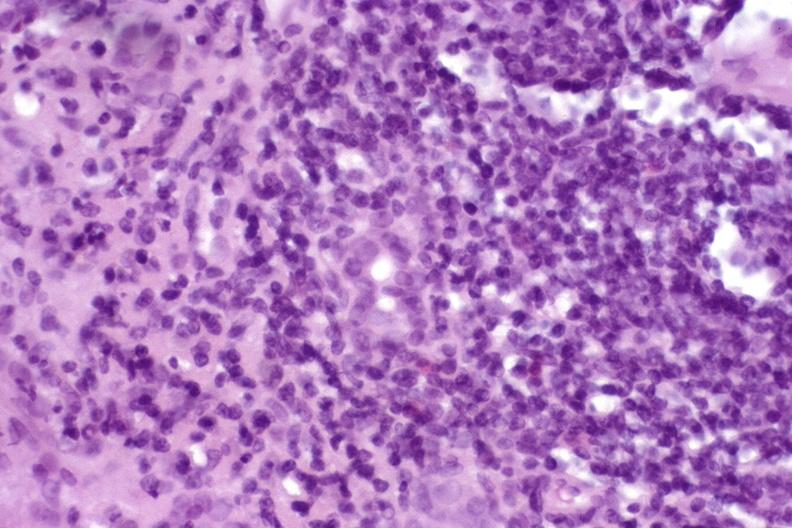does ovary show autoimmune hepatitis?
Answer the question using a single word or phrase. No 